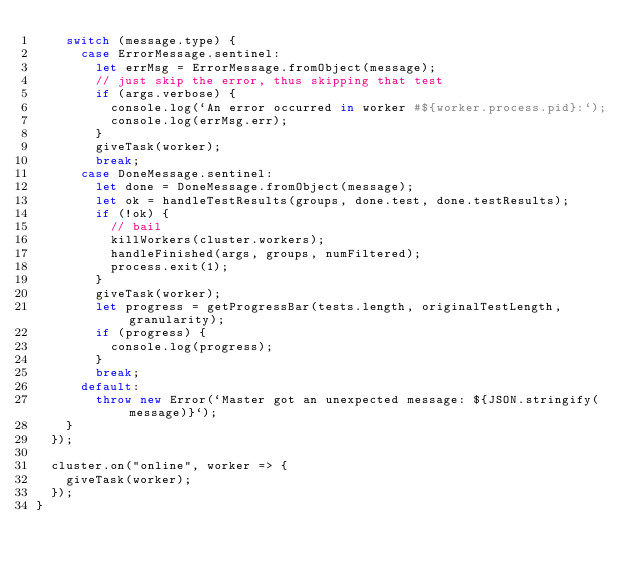<code> <loc_0><loc_0><loc_500><loc_500><_JavaScript_>    switch (message.type) {
      case ErrorMessage.sentinel:
        let errMsg = ErrorMessage.fromObject(message);
        // just skip the error, thus skipping that test
        if (args.verbose) {
          console.log(`An error occurred in worker #${worker.process.pid}:`);
          console.log(errMsg.err);
        }
        giveTask(worker);
        break;
      case DoneMessage.sentinel:
        let done = DoneMessage.fromObject(message);
        let ok = handleTestResults(groups, done.test, done.testResults);
        if (!ok) {
          // bail
          killWorkers(cluster.workers);
          handleFinished(args, groups, numFiltered);
          process.exit(1);
        }
        giveTask(worker);
        let progress = getProgressBar(tests.length, originalTestLength, granularity);
        if (progress) {
          console.log(progress);
        }
        break;
      default:
        throw new Error(`Master got an unexpected message: ${JSON.stringify(message)}`);
    }
  });

  cluster.on("online", worker => {
    giveTask(worker);
  });
}
</code> 